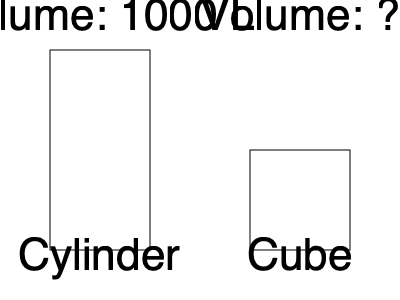A restaurant's waste compactor can reduce the volume of recyclable materials by 60%. If a cylindrical container with a volume of 1000 liters is compacted and transferred to a cubic container, what is the volume of the cubic container needed to hold the compacted waste? To solve this problem, we need to follow these steps:

1. Calculate the volume of the waste after compaction:
   - Original volume = 1000 liters
   - Reduction percentage = 60%
   - Remaining volume = 100% - 60% = 40% of original volume
   - Compacted volume = $1000 \times 0.40 = 400$ liters

2. The cubic container needs to hold 400 liters of compacted waste.

3. To find the dimensions of the cubic container, we need to calculate the cube root of the volume:
   - Side length of cube = $\sqrt[3]{400} \approx 7.37$ liters

4. Round up to the nearest whole number to ensure the container can hold all the waste:
   - Side length of cube ≈ 8 liters

5. Calculate the final volume of the cubic container:
   - Volume of cube = $8^3 = 512$ liters

Therefore, the cubic container needs to have a volume of 512 liters to hold the compacted waste.
Answer: 512 liters 